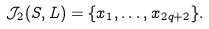<formula> <loc_0><loc_0><loc_500><loc_500>\mathcal { J } _ { 2 } ( S , L ) = \{ x _ { 1 } , \dots , x _ { 2 q + 2 } \} .</formula> 